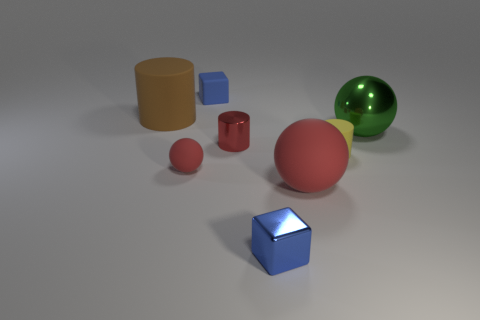Subtract all brown cubes. Subtract all brown balls. How many cubes are left? 2 Add 1 big purple matte balls. How many objects exist? 9 Subtract all blocks. How many objects are left? 6 Add 3 brown matte cylinders. How many brown matte cylinders exist? 4 Subtract 0 blue spheres. How many objects are left? 8 Subtract all blue metallic cubes. Subtract all large green metal things. How many objects are left? 6 Add 1 big brown matte cylinders. How many big brown matte cylinders are left? 2 